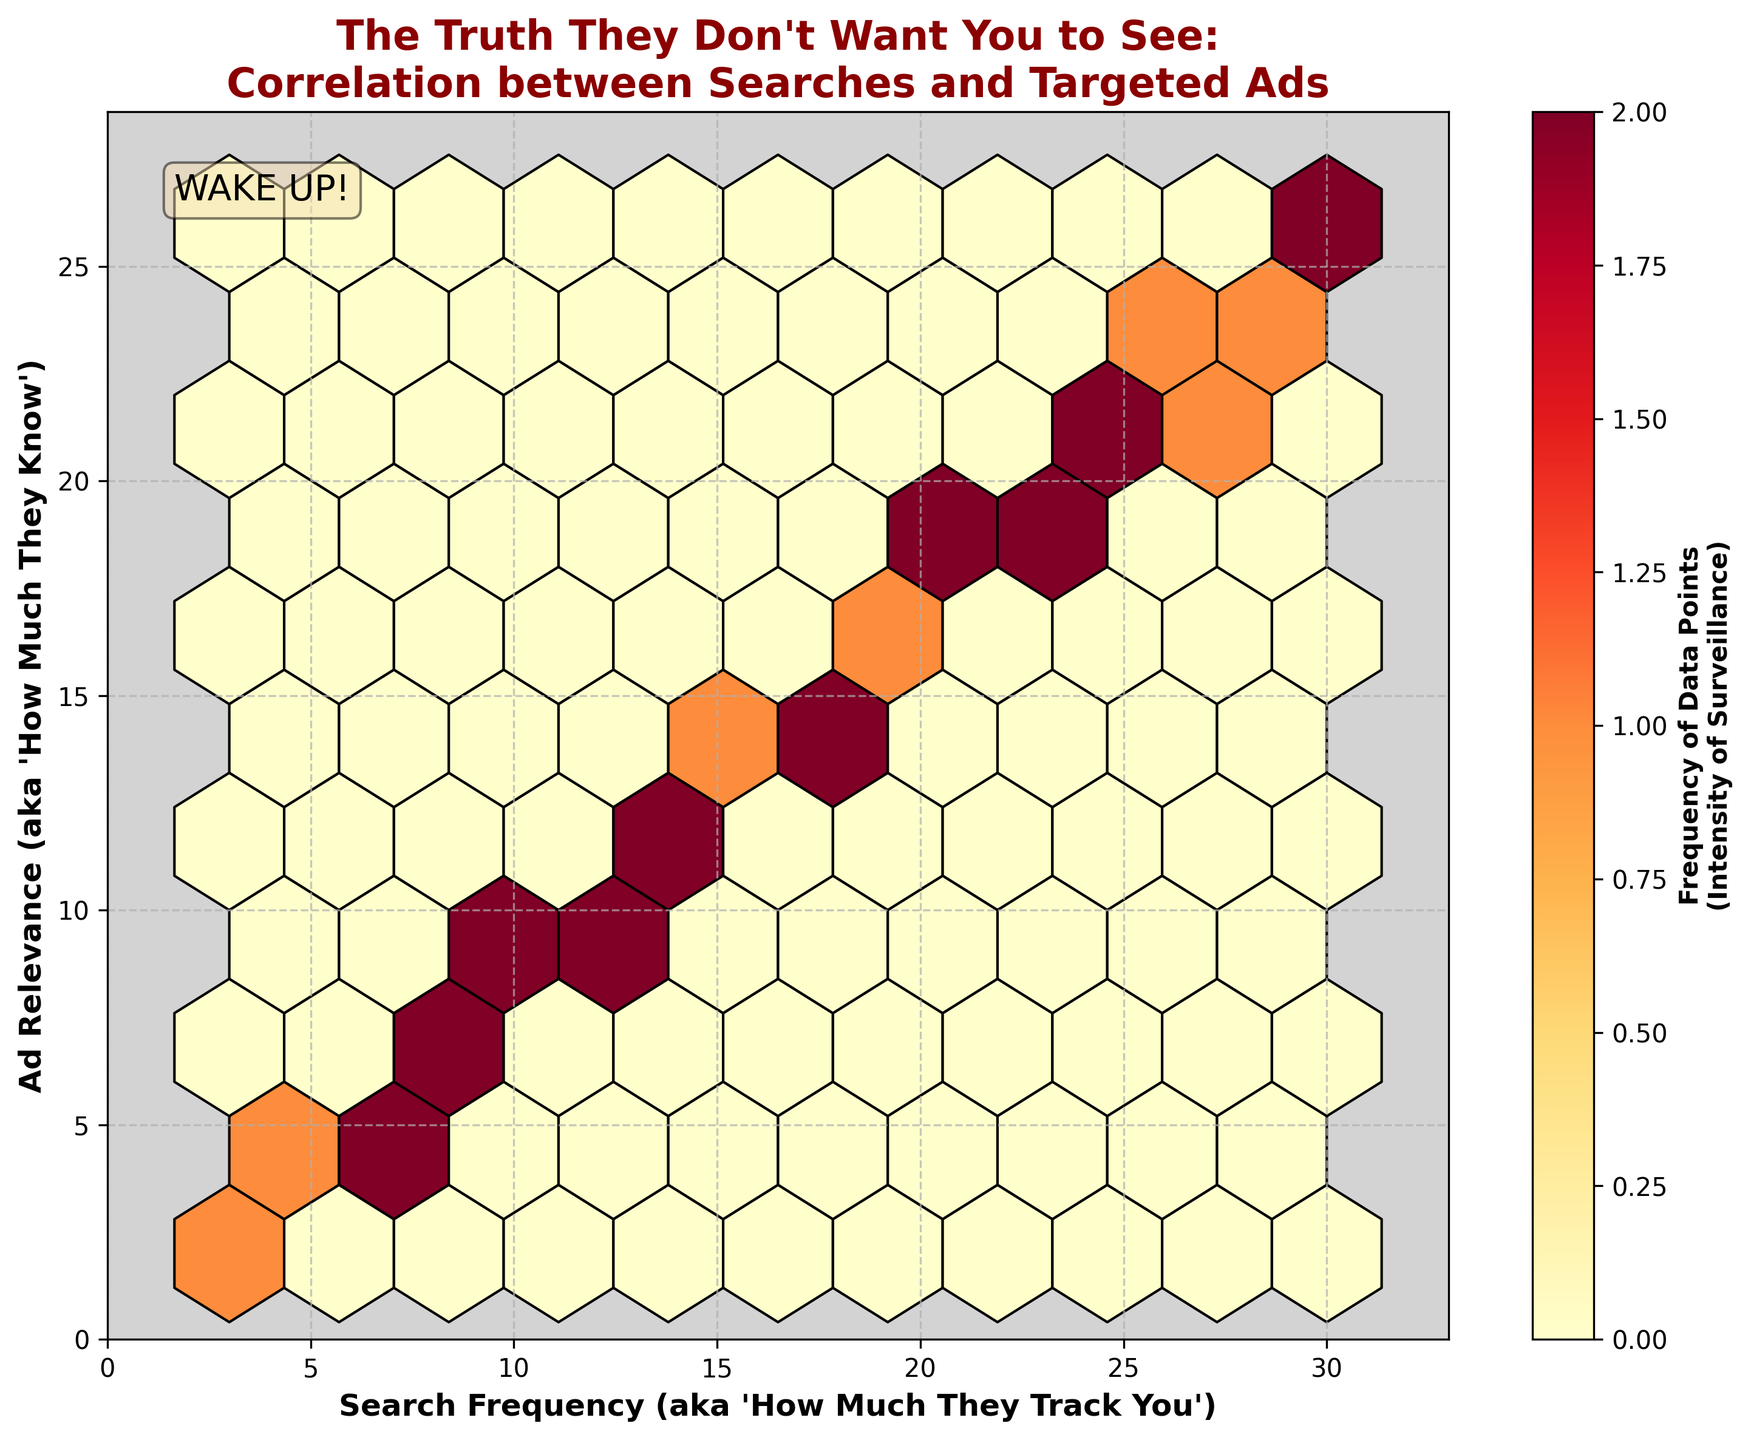What is the title of the figure? The title is displayed at the top of the figure and reads "The Truth They Don't Want You to See: Correlation between Searches and Targeted Ads."
Answer: The Truth They Don't Want You to See: Correlation between Searches and Targeted Ads What does the x-axis represent? The x-axis label is "Search Frequency (aka 'How Much They Track You')." This indicates the frequency of user searches on the shopping platform.
Answer: Search Frequency What does the y-axis represent? The y-axis label is "Ad Relevance (aka 'How Much They Know')." This indicates how relevant the advertisements are to the user based on their search frequency.
Answer: Ad Relevance What color indicates the highest frequency of data points? The hexbin plot uses a color map 'YlOrRd', where lighter shades (like yellow) indicate lower frequencies and darker shades (like red) indicate higher frequencies. The darkest red patches reflect the highest frequency of data points.
Answer: Dark Red What is the range of search frequency values shown on the x-axis? The x-axis limits are set dynamically based on the maximum value of the search frequency, extending slightly beyond it. The highest search frequency value is 30, so the x-axis range is from 0 to approximately 33.
Answer: 0 to 33 How does the ad relevance generally change as search frequency increases? By observing the clustering of hexagons, one can see that areas of higher ad relevance (higher y-values) correspond to areas of higher search frequency (higher x-values). This indicates a positive correlation between search frequency and ad relevance.
Answer: Increases Which area in the plot has the most frequent data points? The densest area is indicated by the darkest red color in the hexbin plot. This area is around a search frequency of 20-25 and an ad relevance of 18-22.
Answer: Around (20-25, 18-22) What does the color bar represent? The color bar on the right side of the figure shows the number of occurrences of data points within each hexagon, effectively indicating the intensity of surveillance. It ranges from lower values in yellow to higher values in dark red.
Answer: Number of occurrences Calculate the average search frequency of the data points. Sum up all search frequency values (10 + 15 + 8 + 20 + 12 + 18 + 25 + 30 + 5 + 22 + 14 + 28 + 16 + 9 + 11 + 23 + 7 + 19 + 13 + 27 + 6 + 21 + 17 + 24 + 29 + 3 + 26), then divide by the number of data points (27). Average = 405 / 27 = 15.
Answer: 15 Given the positive correlation indicated in the plot, if a user has a search frequency of 25, what would you expect their ad relevance to be? Based on the positive correlation shown between search frequency and ad relevance, we can predict that a user with a search frequency of 25 will have an ad relevance close to the corresponding values seen in the plot. From the hexbin plot, search frequency of 25 has ad relevance values around 22.
Answer: Around 22 